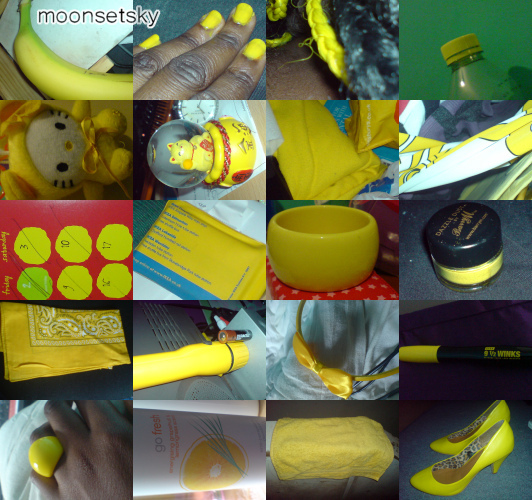Identify the text contained in this image. moonsetsky WINKS 